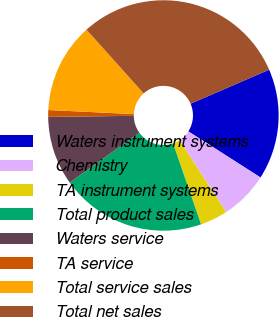Convert chart. <chart><loc_0><loc_0><loc_500><loc_500><pie_chart><fcel>Waters instrument systems<fcel>Chemistry<fcel>TA instrument systems<fcel>Total product sales<fcel>Waters service<fcel>TA service<fcel>Total service sales<fcel>Total net sales<nl><fcel>15.54%<fcel>6.79%<fcel>3.87%<fcel>20.4%<fcel>9.7%<fcel>0.95%<fcel>12.62%<fcel>30.13%<nl></chart> 